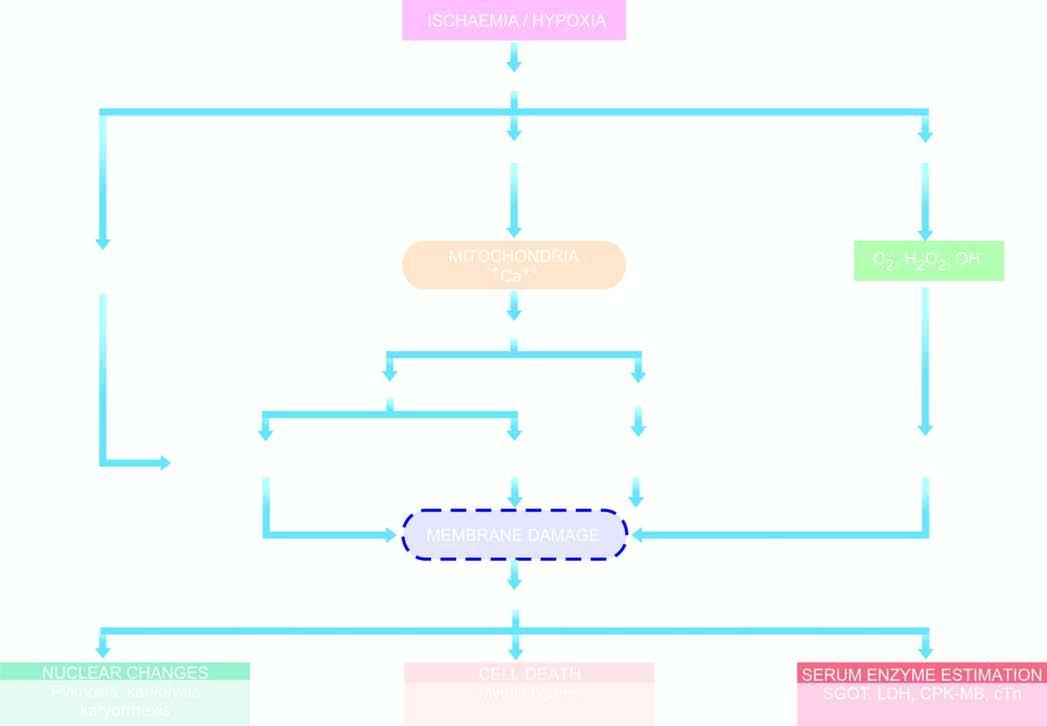what is caused by hypoxia/ischaemia?
Answer the question using a single word or phrase. Sequence of events 